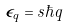Convert formula to latex. <formula><loc_0><loc_0><loc_500><loc_500>\epsilon _ { q } = s \hbar { q }</formula> 